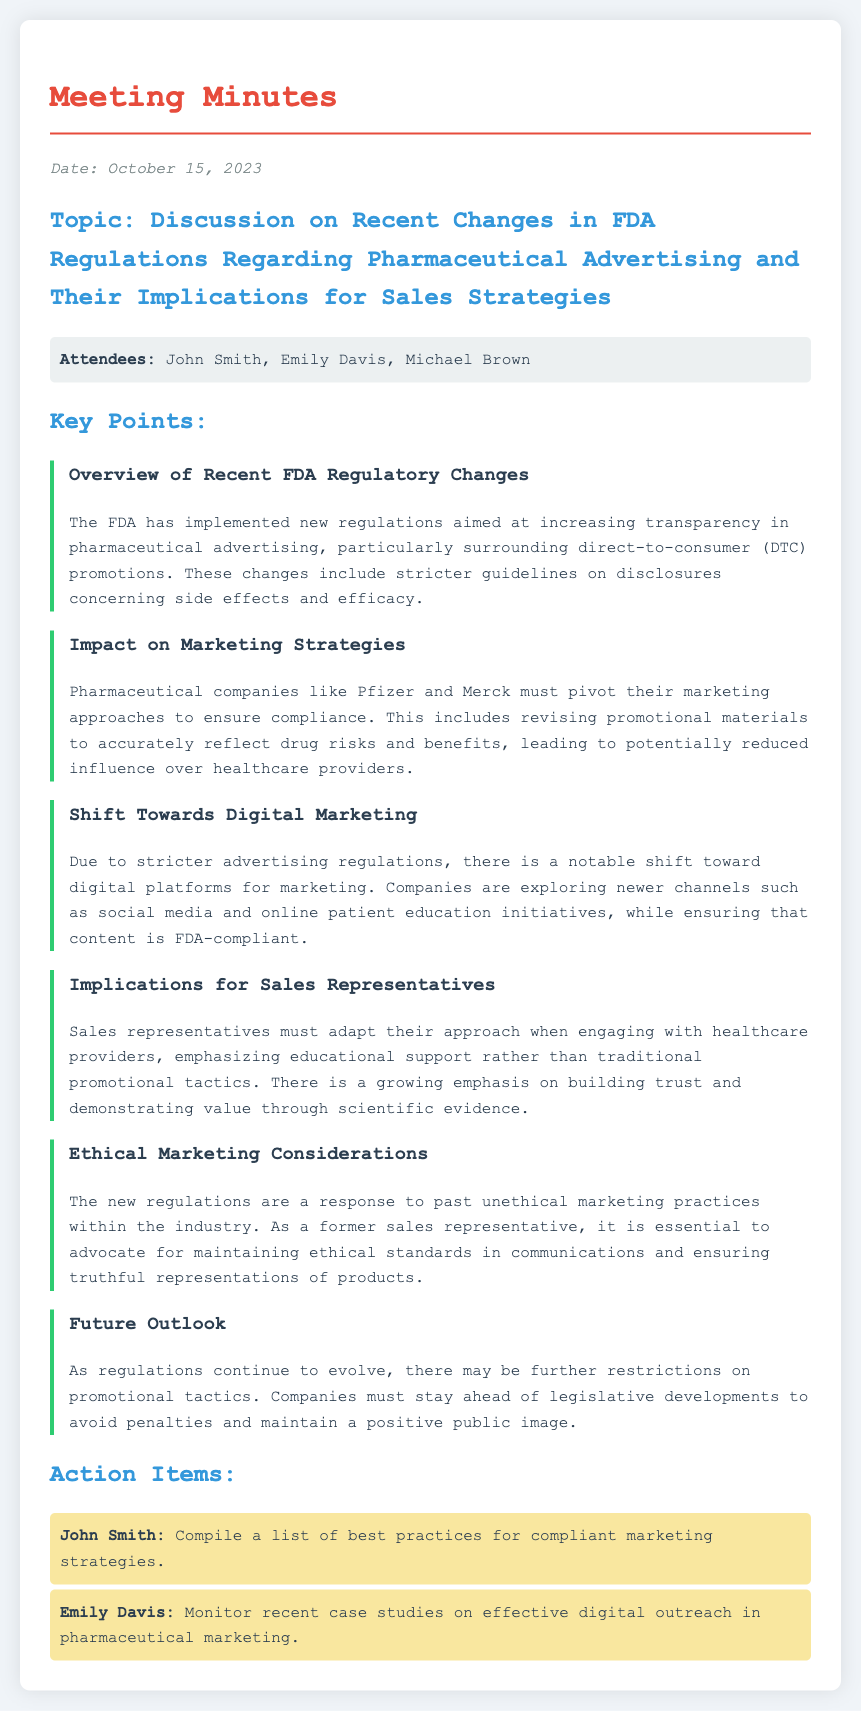What is the date of the meeting? The date of the meeting is mentioned in the document as October 15, 2023.
Answer: October 15, 2023 Who are the attendees listed in the document? The document lists the attendees as John Smith, Emily Davis, and Michael Brown.
Answer: John Smith, Emily Davis, Michael Brown What key topic is discussed in the meeting? The key topic discussed in the meeting revolves around recent changes in FDA regulations regarding pharmaceutical advertising.
Answer: Recent changes in FDA regulations regarding pharmaceutical advertising What is one impact of the new marketing strategies on healthcare providers? It is stated that sales representatives must adapt their approach, emphasizing educational support over traditional promotional tactics.
Answer: Emphasizing educational support What does the document suggest as a shift in marketing strategies? The document indicates a shift towards digital platforms for marketing, such as social media and online patient education initiatives.
Answer: Digital platforms What action item was assigned to John Smith? The document specifies that John Smith is tasked with compiling a list of best practices for compliant marketing strategies.
Answer: Compile a list of best practices for compliant marketing strategies What ethical consideration is mentioned in the meeting minutes? It is emphasized that the new regulations are a response to past unethical marketing practices within the industry.
Answer: Response to past unethical marketing practices What is a future outlook mentioned in the document? The document discusses the possibility of further restrictions on promotional tactics as regulations evolve.
Answer: Further restrictions on promotional tactics 